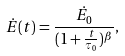Convert formula to latex. <formula><loc_0><loc_0><loc_500><loc_500>\dot { E } ( t ) = \frac { \dot { E _ { 0 } } } { ( 1 + \frac { t } { \tau _ { 0 } } ) ^ { \beta } } ,</formula> 